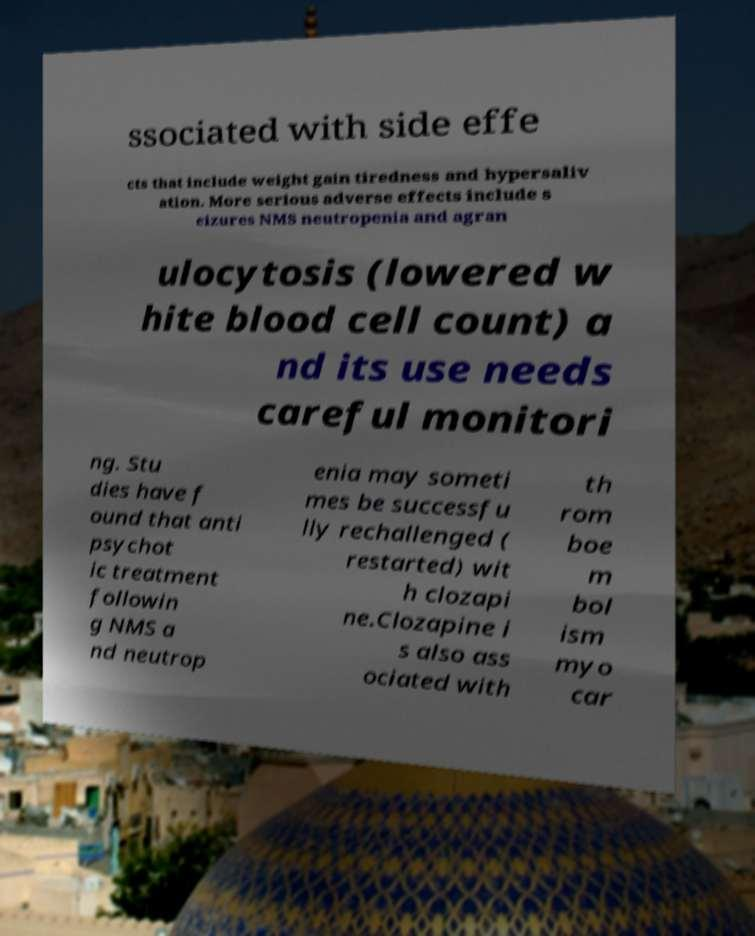I need the written content from this picture converted into text. Can you do that? ssociated with side effe cts that include weight gain tiredness and hypersaliv ation. More serious adverse effects include s eizures NMS neutropenia and agran ulocytosis (lowered w hite blood cell count) a nd its use needs careful monitori ng. Stu dies have f ound that anti psychot ic treatment followin g NMS a nd neutrop enia may someti mes be successfu lly rechallenged ( restarted) wit h clozapi ne.Clozapine i s also ass ociated with th rom boe m bol ism myo car 